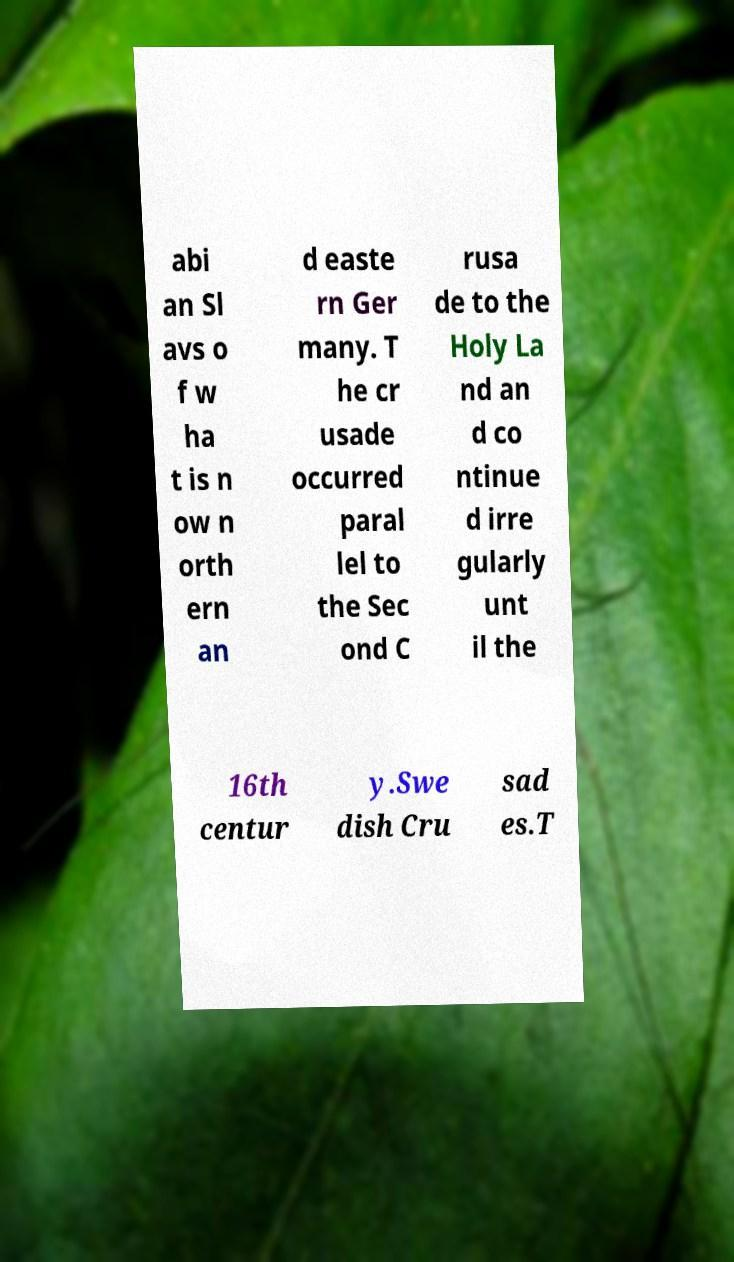Please read and relay the text visible in this image. What does it say? abi an Sl avs o f w ha t is n ow n orth ern an d easte rn Ger many. T he cr usade occurred paral lel to the Sec ond C rusa de to the Holy La nd an d co ntinue d irre gularly unt il the 16th centur y.Swe dish Cru sad es.T 